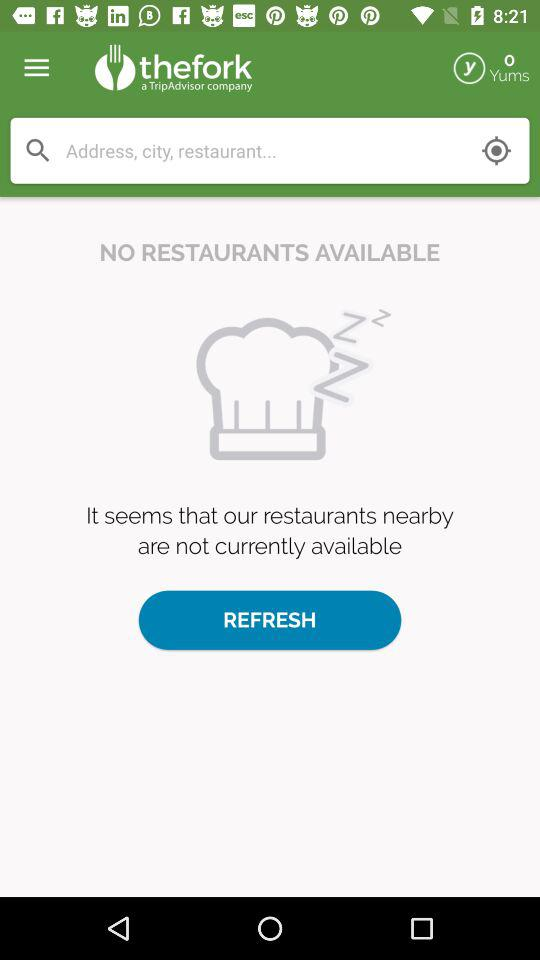How many Yums are there? There are 0 Yums. 